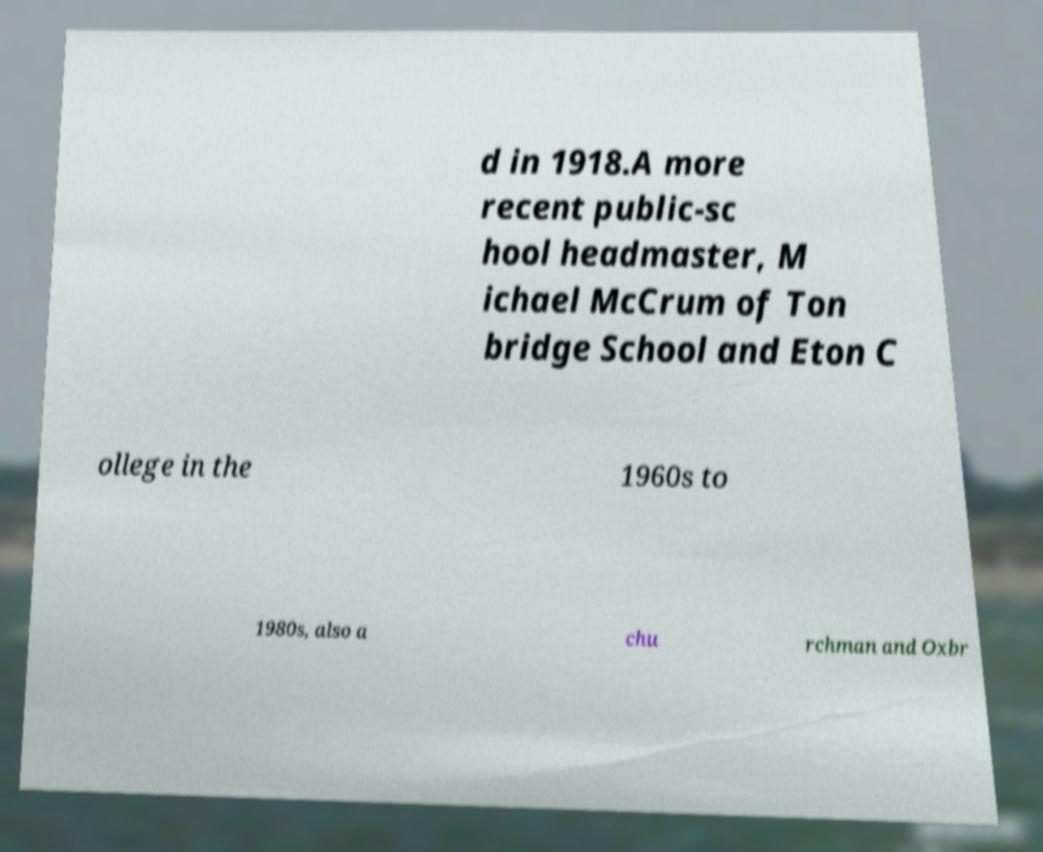Can you read and provide the text displayed in the image?This photo seems to have some interesting text. Can you extract and type it out for me? d in 1918.A more recent public-sc hool headmaster, M ichael McCrum of Ton bridge School and Eton C ollege in the 1960s to 1980s, also a chu rchman and Oxbr 